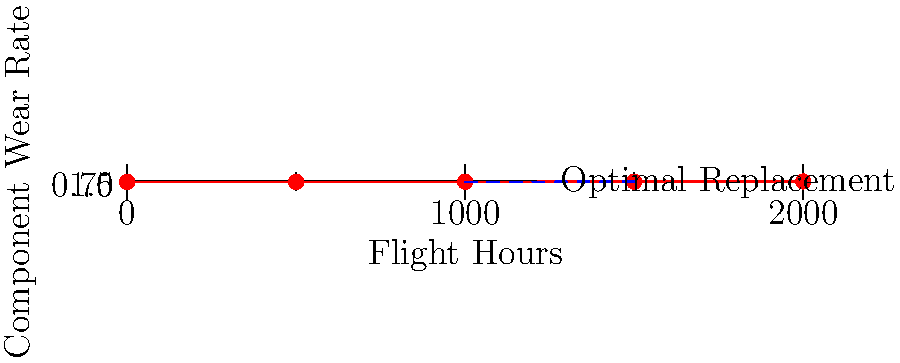Given the graph showing the relationship between flight hours and component wear rate for a critical aircraft part, at approximately how many flight hours should the component be replaced to optimize maintenance efficiency and ensure safety? To determine the optimal maintenance schedule, we need to analyze the graph and identify the point where the wear rate begins to increase more rapidly. This approach balances the need for safety with maintenance efficiency.

Step 1: Observe the overall trend of the graph.
The wear rate increases gradually at first, then more rapidly as flight hours increase.

Step 2: Identify the inflection point.
The curve begins to steepen more noticeably around 1000-1500 flight hours.

Step 3: Locate the "knee" of the curve.
The point where the curve begins to bend more sharply is around 1250 flight hours.

Step 4: Consider safety margins.
It's prudent to replace the component before it reaches critical wear levels. The 1250-hour mark provides a good balance between maximizing component life and ensuring safety.

Step 5: Factor in practical considerations.
Regular maintenance intervals are often set at round numbers for ease of scheduling. The closest round number to our identified optimal point is 1200 or 1300 flight hours.

Given these factors, the optimal replacement time for this component would be approximately 1200-1300 flight hours, with 1250 being the most precise estimate based on the graph.
Answer: 1250 flight hours 